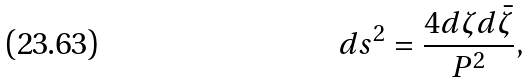<formula> <loc_0><loc_0><loc_500><loc_500>d s ^ { 2 } = \frac { 4 d \zeta d \bar { \zeta } } { P ^ { 2 } } ,</formula> 